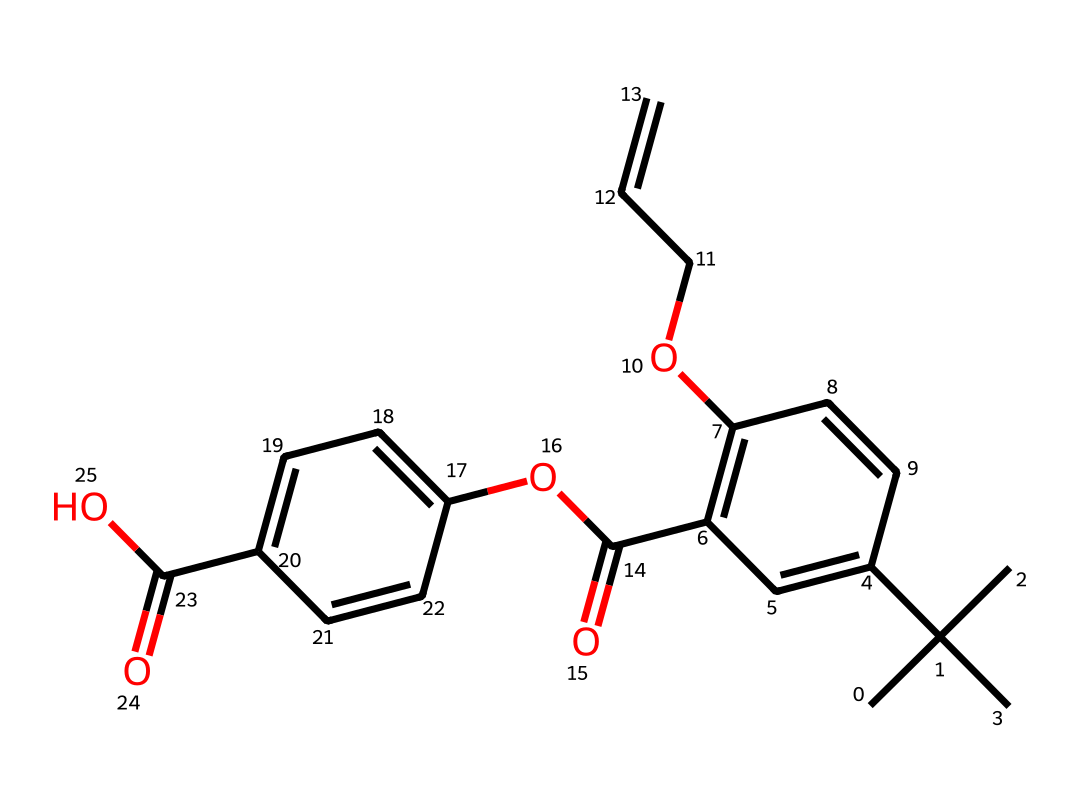How many carbon atoms are in the structure? By analyzing the SMILES representation, we can count the carbon atoms represented by the 'C' characters and any carbon atoms represented in cycles. In this case, there are 20 carbon atoms total in the structure.
Answer: 20 What is the functional group indicated by “C(=O)O” in the structure? The part “C(=O)O” indicates a carboxyl group, which is characteristic of acids. This is identified by the presence of a carbon atom doubly bonded to oxygen and singly bonded to a hydroxyl group (-OH).
Answer: carboxyl group How many double bonds can be found in the structure? To find the number of double bonds, we look for connections where a carbon is double bonded to another atom in the SMILES notation. There are multiple occurrences of '(=)' indicating double bonds. Counting these, there are 5 double bonds present.
Answer: 5 What types of interior finishes could benefit from this liquid? The structure suggests that this liquid could be used for various finishes, particularly due to the inclusion of color-producing units. This includes coatings, paints, or dyes specifically formulated for interior design applications.
Answer: coatings What might be the solubility of this compound in water? Solubility can be inferred from the presence of hydroxyl (-OH) groups, which are typically polar and increase water solubility. However, due to the extensive hydrocarbon portion and multiple rings, the overall solubility may be low. Thus, it is likely to be partially soluble in water.
Answer: partially soluble What is the significance of the cyclic components in this structure? The cyclic components typically enhance the stability of the compound and may contribute to certain aesthetic properties associated with color or light absorption, which could be beneficial in design applications.
Answer: stability and aesthetics 